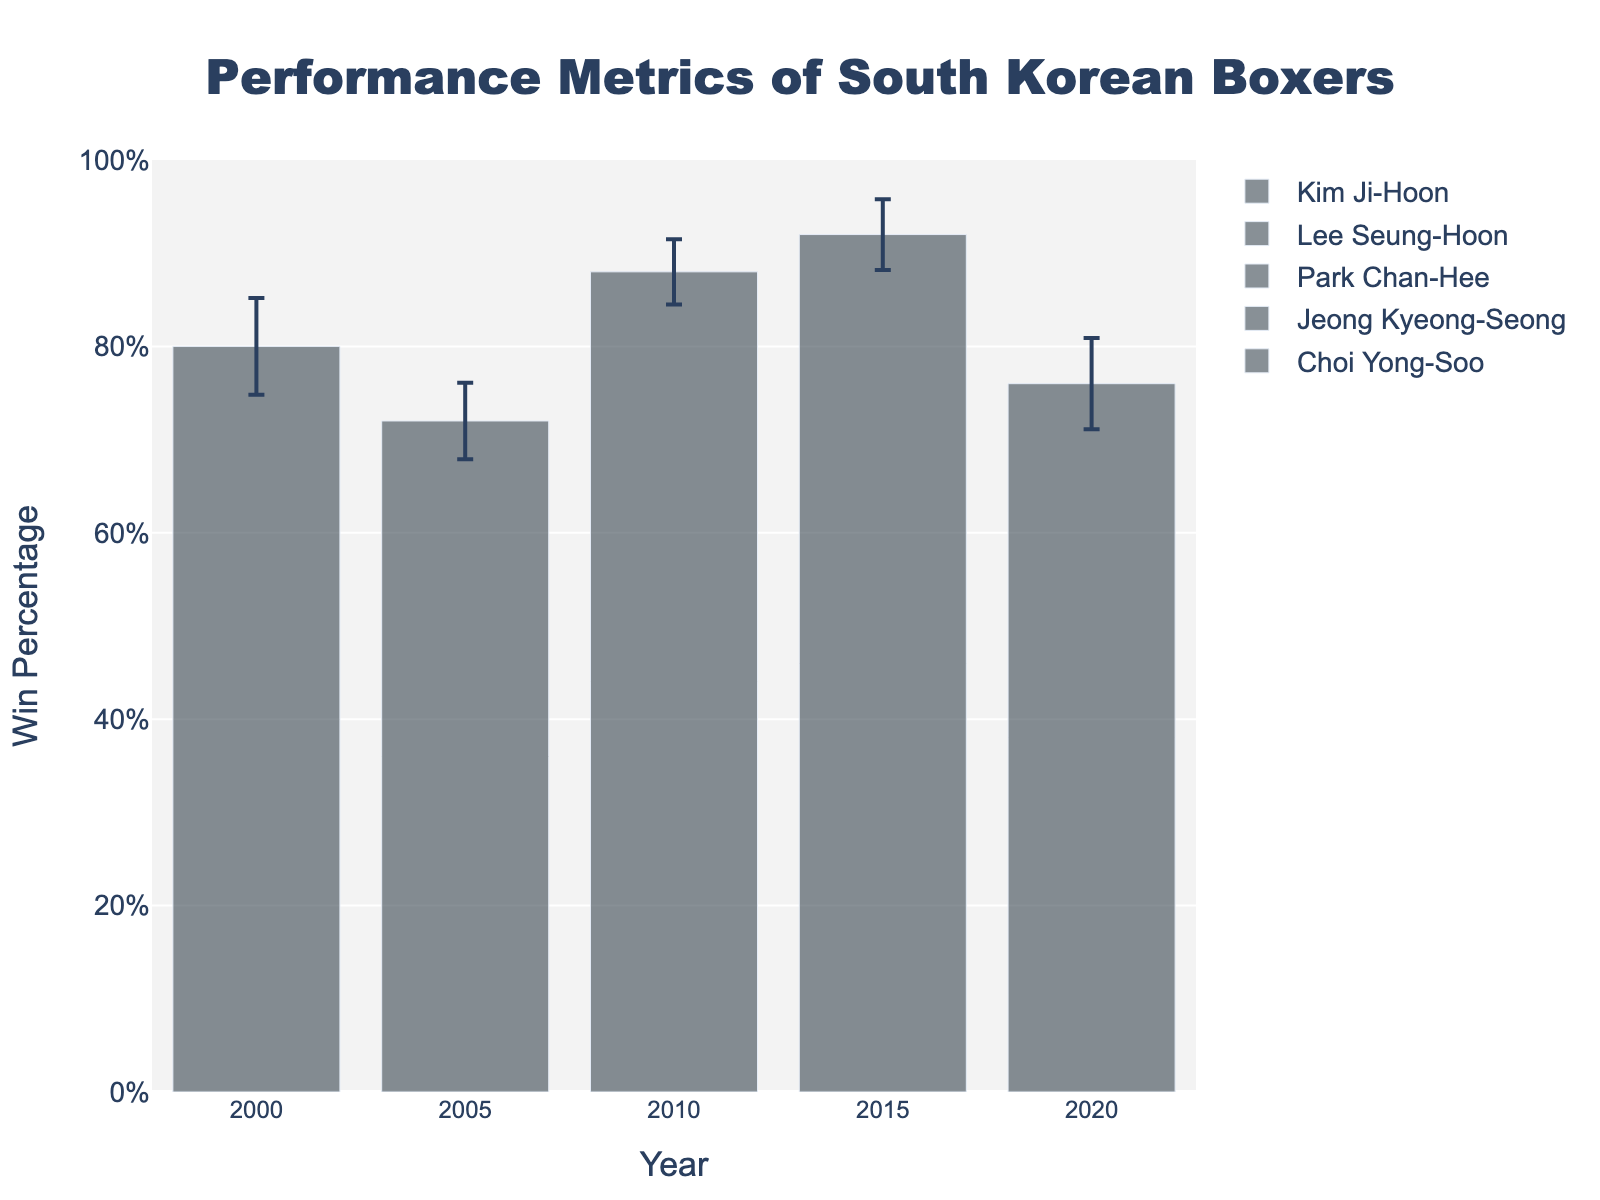What's the title of the figure? The title of a figure is typically displayed prominently at the top. The title here is "Performance Metrics of South Korean Boxers".
Answer: Performance Metrics of South Korean Boxers What does the y-axis represent? The y-axis represents the "Win Percentage". This information is typically displayed along the axis.
Answer: Win Percentage Which boxer had the highest win percentage? By looking at the height of the bars, the highest bar will correspond to the highest win percentage. Jeong Kyeong-Seong in 2015 has the highest win percentage.
Answer: Jeong Kyeong-Seong How many boxers' performance metrics are displayed on the figure? Each bar represents a boxer, so counting the number of bars gives the number of boxers. There are 5 bars.
Answer: 5 What is the win percentage for Lee Seung-Hoon? Look at the bar labeled 2005 for Lee Seung-Hoon and check the height of the bar, which corresponds to the win percentage. Lee Seung-Hoon's win percentage is 72%.
Answer: 72% Which year had the lowest win percentage, and what was it? Identify the bar with the smallest height, which indicates the lowest win percentage. The 2020 bar for Choi Yong-Soo has the lowest win percentage of 76%.
Answer: 2020, 76% What's the difference in win percentage between Park Chan-Hee and Choi Yong-Soo? Subtract Choi Yong-Soo's win percentage from Park Chan-Hee's. 88% - 76% = 12%.
Answer: 12% Which boxer had the highest training duration standard deviation, and what was it? The training duration standard deviation is indicated by the error bars. The longest error bar belongs to Choi Yong-Soo in 2020 with 4.9.
Answer: Choi Yong-Soo, 4.9 How does the win percentage of Kim Ji-Hoon compare to that of Jeong Kyeong-Seong? Compare the heights of the bars for Kim Ji-Hoon in 2000 and Jeong Kyeong-Seong in 2015. Jeong Kyeong-Seong (92%) has a higher win percentage than Kim Ji-Hoon (80%).
Answer: Jeong Kyeong-Seong has a higher win percentage What's the average win percentage of all boxers? Sum the win percentages of all the boxers and divide by the number of boxers. (80 + 72 + 88 + 92 + 76) / 5 = 81.6%.
Answer: 81.6% 